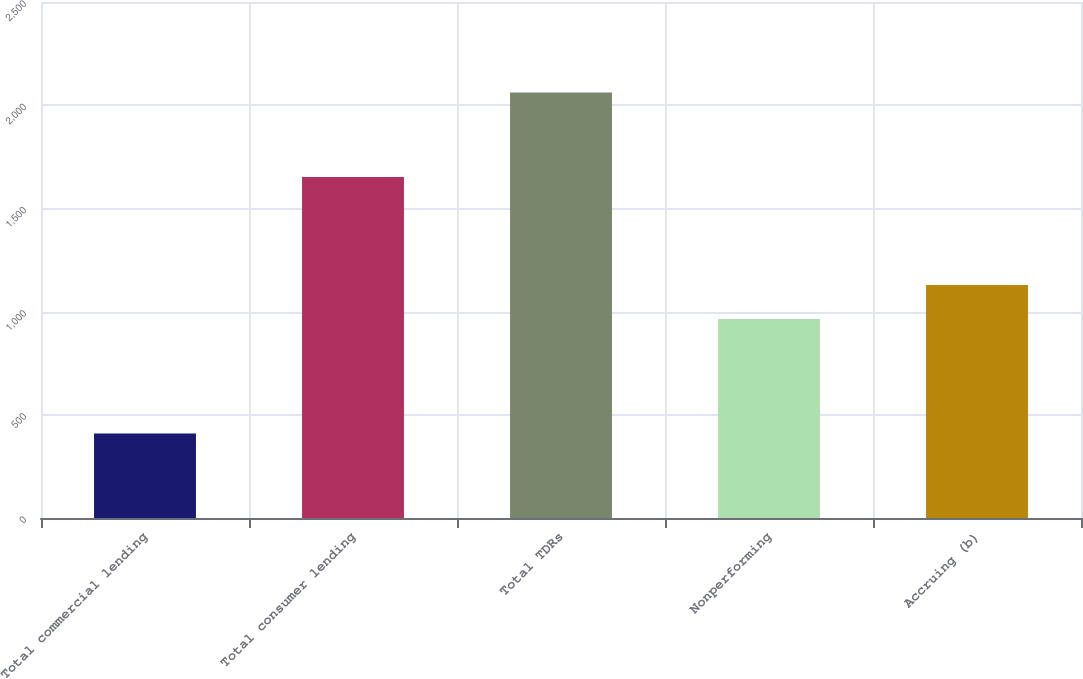Convert chart. <chart><loc_0><loc_0><loc_500><loc_500><bar_chart><fcel>Total commercial lending<fcel>Total consumer lending<fcel>Total TDRs<fcel>Nonperforming<fcel>Accruing (b)<nl><fcel>409<fcel>1652<fcel>2061<fcel>964<fcel>1129.2<nl></chart> 